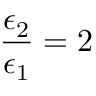Convert formula to latex. <formula><loc_0><loc_0><loc_500><loc_500>\frac { \epsilon _ { 2 } } { \epsilon _ { 1 } } = 2</formula> 